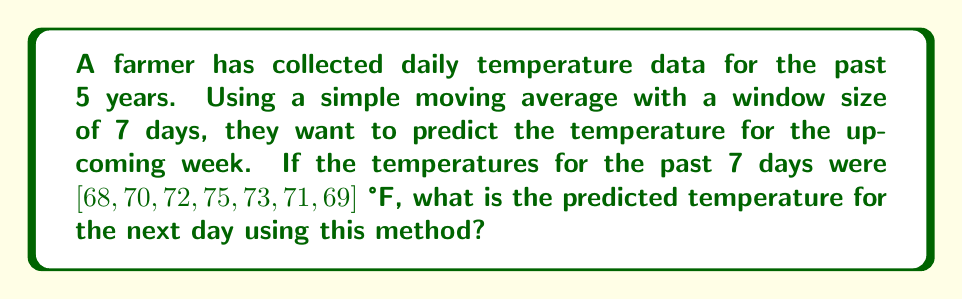Show me your answer to this math problem. To solve this problem, we'll use the simple moving average (SMA) method, which is a basic form of time series analysis. Here are the steps:

1. Understand the SMA formula:
   $$ SMA = \frac{\sum_{i=1}^{n} x_i}{n} $$
   where $n$ is the window size and $x_i$ are the data points.

2. In this case, $n = 7$ (7-day window), and we have the following data points:
   $[68, 70, 72, 75, 73, 71, 69]$

3. Apply the SMA formula:
   $$ SMA = \frac{68 + 70 + 72 + 75 + 73 + 71 + 69}{7} $$

4. Calculate the sum of the temperatures:
   $$ 68 + 70 + 72 + 75 + 73 + 71 + 69 = 498 $$

5. Divide the sum by the window size (7):
   $$ \frac{498}{7} = 71.14285714 $$

6. Round to two decimal places for practical use:
   $$ 71.14 \text{ °F} $$

This value represents the predicted temperature for the next day based on the 7-day simple moving average.
Answer: 71.14 °F 